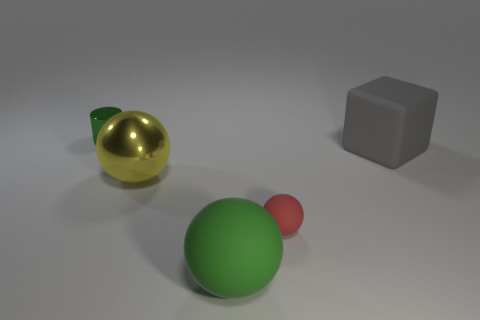What number of cyan spheres have the same size as the yellow metallic sphere?
Give a very brief answer. 0. Are there fewer tiny red rubber things left of the tiny red rubber sphere than blocks behind the small green cylinder?
Your answer should be compact. No. What number of shiny objects are either blocks or green balls?
Make the answer very short. 0. The large gray matte thing is what shape?
Your answer should be very brief. Cube. What is the material of the green thing that is the same size as the matte cube?
Your answer should be compact. Rubber. How many small things are either gray objects or green things?
Your response must be concise. 1. Is there a gray shiny cylinder?
Keep it short and to the point. No. The yellow thing that is made of the same material as the cylinder is what size?
Your answer should be compact. Large. Does the cylinder have the same material as the large gray object?
Provide a succinct answer. No. What number of other things are the same material as the small red thing?
Your answer should be compact. 2. 